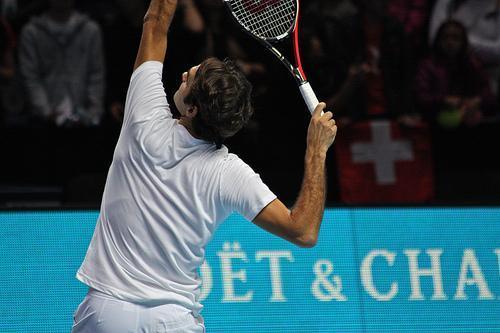How many people are playing football on the field?
Give a very brief answer. 0. 